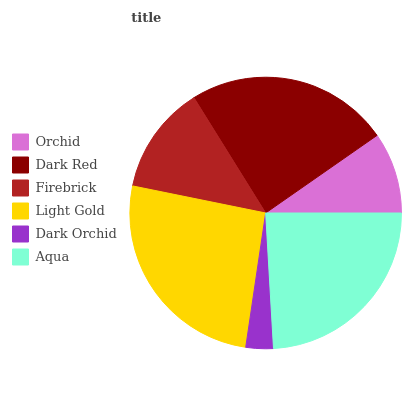Is Dark Orchid the minimum?
Answer yes or no. Yes. Is Light Gold the maximum?
Answer yes or no. Yes. Is Dark Red the minimum?
Answer yes or no. No. Is Dark Red the maximum?
Answer yes or no. No. Is Dark Red greater than Orchid?
Answer yes or no. Yes. Is Orchid less than Dark Red?
Answer yes or no. Yes. Is Orchid greater than Dark Red?
Answer yes or no. No. Is Dark Red less than Orchid?
Answer yes or no. No. Is Aqua the high median?
Answer yes or no. Yes. Is Firebrick the low median?
Answer yes or no. Yes. Is Light Gold the high median?
Answer yes or no. No. Is Light Gold the low median?
Answer yes or no. No. 